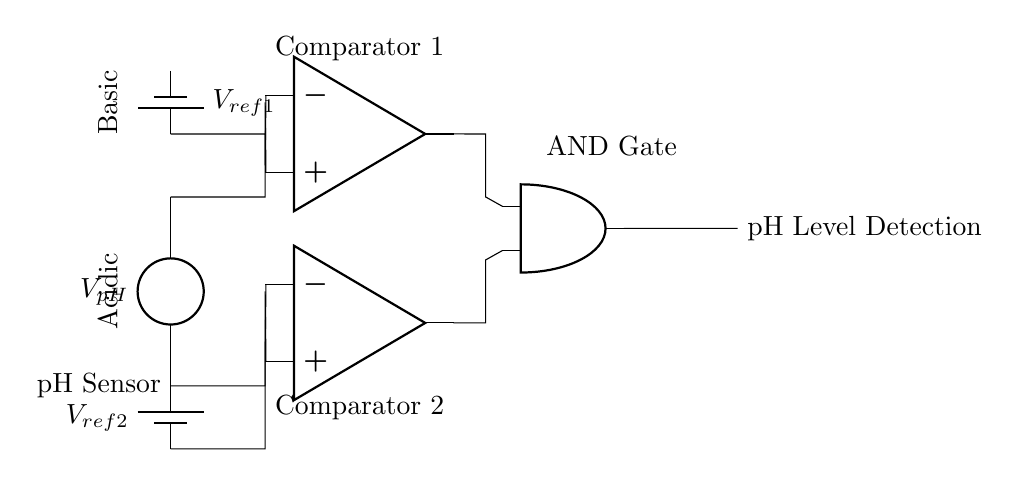What type of logic gate is used in this circuit? The circuit includes an AND gate which processes inputs from two comparators. Thus, it uses an AND gate as its primary logic component to determine the pH level detection.
Answer: AND gate What are the reference voltages in the pH level detection circuit? The circuit features two reference voltages labeled Vref1 and Vref2, which are supplied by batteries to the comparators for comparison against the pH sensor voltage.
Answer: Vref1 and Vref2 What does the output of the AND gate indicate? The output signifies the pH level detection, indicating whether the detected pH level is in the acidic or basic range based on the comparator outputs feeding the AND gate.
Answer: pH Level Detection What is the purpose of the pH sensor in this circuit? The pH sensor measures the voltage corresponding to the pH level of the chemical solution, providing a voltage output that is processed by the comparators.
Answer: Measure pH level How many operational amplifiers are present in the circuit? The circuit has two operational amplifiers used as comparators to compare the sensor voltage against the reference voltages.
Answer: Two What conditions must be met for the AND gate to output a high signal? Both inputs to the AND gate must receive high signals from the operational amplifiers, which occur only if the pH sensor voltage is above Vref2 (for acidic) and below Vref1 (for basic).
Answer: Both inputs high 